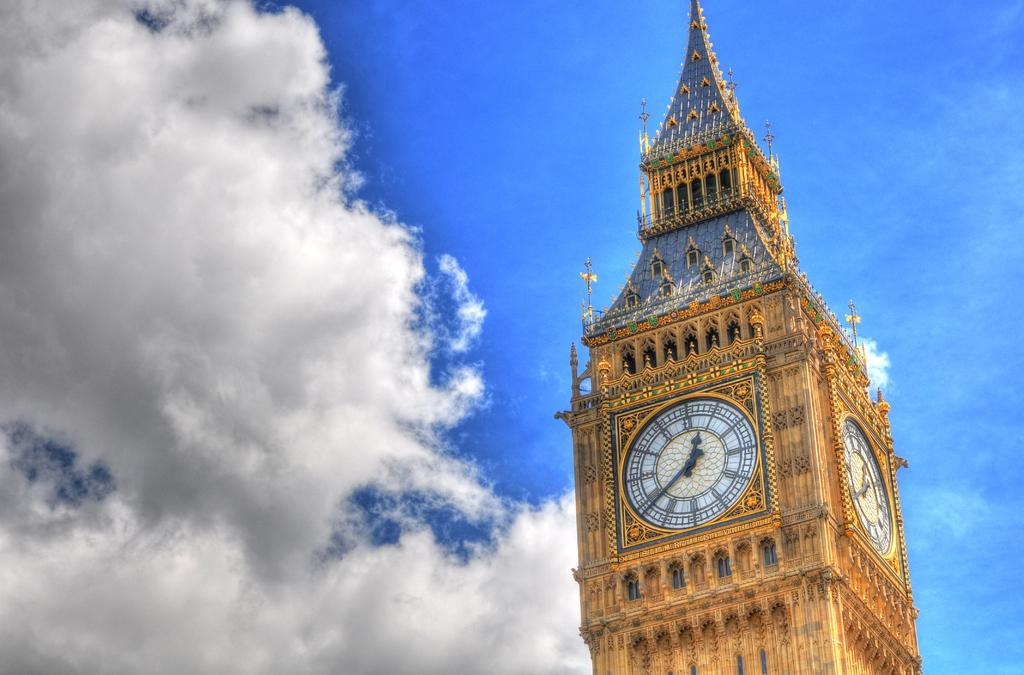What structure is located on the right side of the image? There is a clock tower on the right side of the image. What is the condition of the sky in the image? The sky is cloudy in the image. What type of meat is hanging from the clock tower in the image? There is no meat present in the image; it features a clock tower and a cloudy sky. 